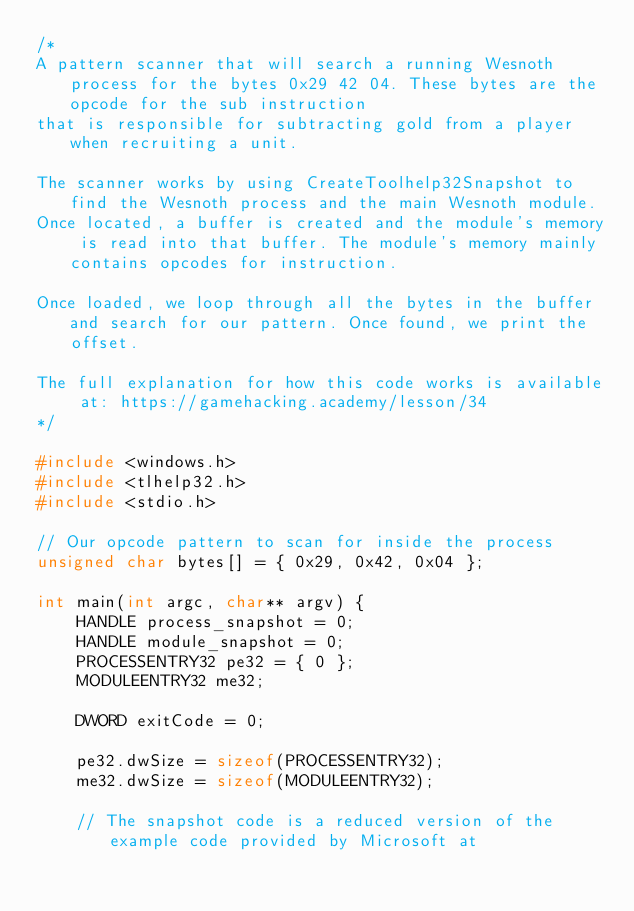<code> <loc_0><loc_0><loc_500><loc_500><_C++_>/*
A pattern scanner that will search a running Wesnoth process for the bytes 0x29 42 04. These bytes are the opcode for the sub instruction 
that is responsible for subtracting gold from a player when recruiting a unit. 

The scanner works by using CreateToolhelp32Snapshot to find the Wesnoth process and the main Wesnoth module. 
Once located, a buffer is created and the module's memory is read into that buffer. The module's memory mainly contains opcodes for instruction.

Once loaded, we loop through all the bytes in the buffer and search for our pattern. Once found, we print the offset.

The full explanation for how this code works is available at: https://gamehacking.academy/lesson/34
*/

#include <windows.h>
#include <tlhelp32.h>
#include <stdio.h>

// Our opcode pattern to scan for inside the process
unsigned char bytes[] = { 0x29, 0x42, 0x04 };

int main(int argc, char** argv) {
	HANDLE process_snapshot = 0;
	HANDLE module_snapshot = 0;
	PROCESSENTRY32 pe32 = { 0 };
	MODULEENTRY32 me32;

	DWORD exitCode = 0;

	pe32.dwSize = sizeof(PROCESSENTRY32);
	me32.dwSize = sizeof(MODULEENTRY32);

	// The snapshot code is a reduced version of the example code provided by Microsoft at </code> 